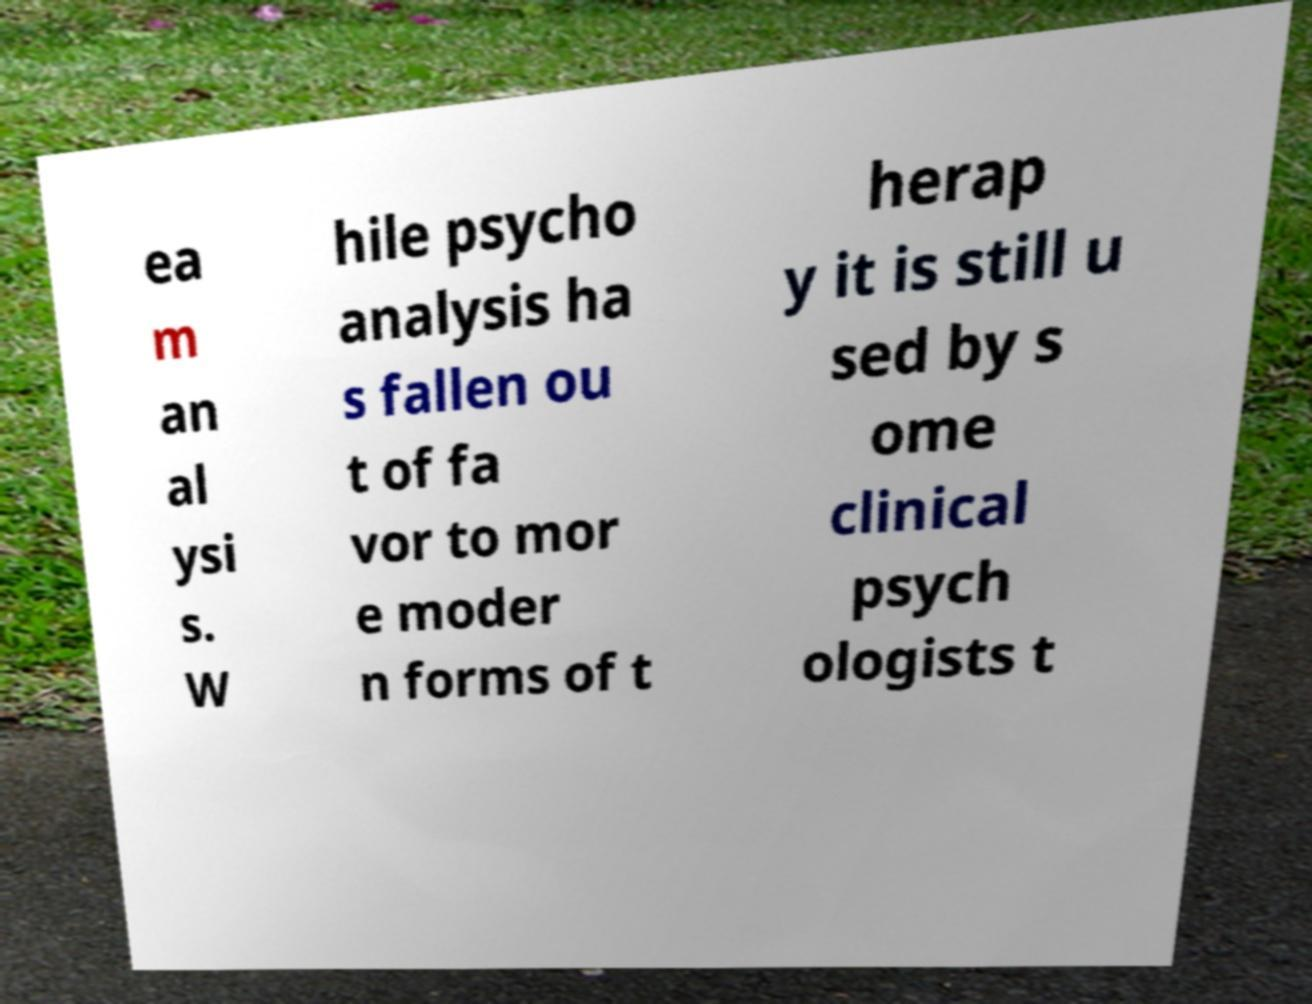Please read and relay the text visible in this image. What does it say? ea m an al ysi s. W hile psycho analysis ha s fallen ou t of fa vor to mor e moder n forms of t herap y it is still u sed by s ome clinical psych ologists t 